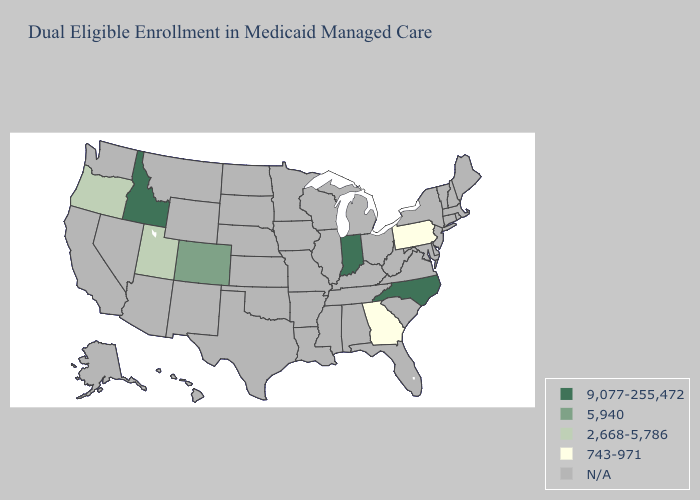What is the lowest value in the USA?
Write a very short answer. 743-971. Name the states that have a value in the range 9,077-255,472?
Answer briefly. Idaho, Indiana, North Carolina. What is the lowest value in the West?
Give a very brief answer. 2,668-5,786. Which states have the highest value in the USA?
Quick response, please. Idaho, Indiana, North Carolina. Which states have the lowest value in the USA?
Keep it brief. Georgia, Pennsylvania. What is the highest value in states that border Washington?
Write a very short answer. 9,077-255,472. What is the value of Nebraska?
Write a very short answer. N/A. Which states hav the highest value in the West?
Answer briefly. Idaho. Name the states that have a value in the range 2,668-5,786?
Write a very short answer. Oregon, Utah. Name the states that have a value in the range N/A?
Short answer required. Alabama, Alaska, Arizona, Arkansas, California, Connecticut, Delaware, Florida, Hawaii, Illinois, Iowa, Kansas, Kentucky, Louisiana, Maine, Maryland, Massachusetts, Michigan, Minnesota, Mississippi, Missouri, Montana, Nebraska, Nevada, New Hampshire, New Jersey, New Mexico, New York, North Dakota, Ohio, Oklahoma, Rhode Island, South Carolina, South Dakota, Tennessee, Texas, Vermont, Virginia, Washington, West Virginia, Wisconsin, Wyoming. 